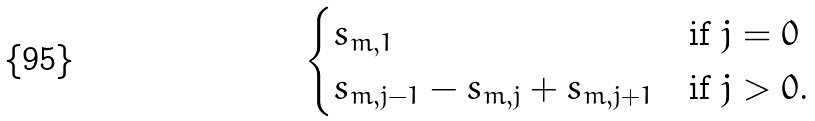<formula> <loc_0><loc_0><loc_500><loc_500>\begin{cases} s _ { m , 1 } & \text {if $j=0$} \\ s _ { m , j - 1 } - s _ { m , j } + s _ { m , j + 1 } & \text {if $j>0$.} \end{cases}</formula> 